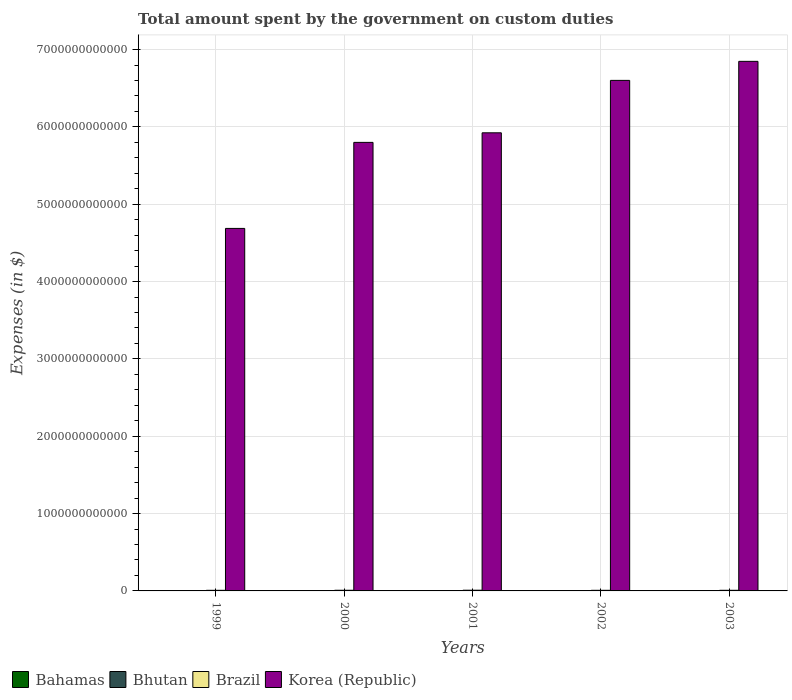How many different coloured bars are there?
Keep it short and to the point. 4. Are the number of bars per tick equal to the number of legend labels?
Ensure brevity in your answer.  Yes. How many bars are there on the 5th tick from the left?
Ensure brevity in your answer.  4. In how many cases, is the number of bars for a given year not equal to the number of legend labels?
Your response must be concise. 0. What is the amount spent on custom duties by the government in Korea (Republic) in 2002?
Make the answer very short. 6.60e+12. Across all years, what is the maximum amount spent on custom duties by the government in Korea (Republic)?
Provide a succinct answer. 6.85e+12. Across all years, what is the minimum amount spent on custom duties by the government in Brazil?
Give a very brief answer. 7.92e+09. In which year was the amount spent on custom duties by the government in Korea (Republic) minimum?
Make the answer very short. 1999. What is the total amount spent on custom duties by the government in Korea (Republic) in the graph?
Your answer should be very brief. 2.99e+13. What is the difference between the amount spent on custom duties by the government in Brazil in 2000 and that in 2003?
Give a very brief answer. 3.68e+08. What is the difference between the amount spent on custom duties by the government in Brazil in 2002 and the amount spent on custom duties by the government in Bhutan in 1999?
Provide a short and direct response. 7.93e+09. What is the average amount spent on custom duties by the government in Bahamas per year?
Provide a short and direct response. 4.08e+08. In the year 2000, what is the difference between the amount spent on custom duties by the government in Korea (Republic) and amount spent on custom duties by the government in Bhutan?
Your answer should be very brief. 5.80e+12. What is the ratio of the amount spent on custom duties by the government in Bhutan in 2001 to that in 2002?
Ensure brevity in your answer.  0.83. Is the amount spent on custom duties by the government in Bahamas in 1999 less than that in 2001?
Offer a very short reply. Yes. What is the difference between the highest and the second highest amount spent on custom duties by the government in Korea (Republic)?
Give a very brief answer. 2.46e+11. What is the difference between the highest and the lowest amount spent on custom duties by the government in Brazil?
Keep it short and to the point. 1.17e+09. Is the sum of the amount spent on custom duties by the government in Bahamas in 2000 and 2002 greater than the maximum amount spent on custom duties by the government in Korea (Republic) across all years?
Provide a short and direct response. No. Is it the case that in every year, the sum of the amount spent on custom duties by the government in Brazil and amount spent on custom duties by the government in Bahamas is greater than the sum of amount spent on custom duties by the government in Bhutan and amount spent on custom duties by the government in Korea (Republic)?
Your answer should be very brief. Yes. What does the 1st bar from the left in 2001 represents?
Keep it short and to the point. Bahamas. Are all the bars in the graph horizontal?
Your answer should be very brief. No. What is the difference between two consecutive major ticks on the Y-axis?
Your response must be concise. 1.00e+12. Does the graph contain any zero values?
Your response must be concise. No. Where does the legend appear in the graph?
Give a very brief answer. Bottom left. What is the title of the graph?
Give a very brief answer. Total amount spent by the government on custom duties. Does "American Samoa" appear as one of the legend labels in the graph?
Provide a succinct answer. No. What is the label or title of the X-axis?
Offer a terse response. Years. What is the label or title of the Y-axis?
Offer a terse response. Expenses (in $). What is the Expenses (in $) in Bahamas in 1999?
Make the answer very short. 3.98e+08. What is the Expenses (in $) of Bhutan in 1999?
Keep it short and to the point. 4.42e+07. What is the Expenses (in $) of Brazil in 1999?
Provide a succinct answer. 7.92e+09. What is the Expenses (in $) in Korea (Republic) in 1999?
Your answer should be very brief. 4.69e+12. What is the Expenses (in $) of Bahamas in 2000?
Your response must be concise. 4.11e+08. What is the Expenses (in $) of Bhutan in 2000?
Your response must be concise. 5.79e+07. What is the Expenses (in $) in Brazil in 2000?
Offer a very short reply. 8.51e+09. What is the Expenses (in $) in Korea (Republic) in 2000?
Make the answer very short. 5.80e+12. What is the Expenses (in $) in Bahamas in 2001?
Offer a very short reply. 4.11e+08. What is the Expenses (in $) in Bhutan in 2001?
Keep it short and to the point. 7.83e+07. What is the Expenses (in $) of Brazil in 2001?
Keep it short and to the point. 9.09e+09. What is the Expenses (in $) in Korea (Republic) in 2001?
Offer a very short reply. 5.92e+12. What is the Expenses (in $) of Bahamas in 2002?
Offer a very short reply. 3.96e+08. What is the Expenses (in $) of Bhutan in 2002?
Your answer should be very brief. 9.45e+07. What is the Expenses (in $) of Brazil in 2002?
Offer a very short reply. 7.97e+09. What is the Expenses (in $) of Korea (Republic) in 2002?
Keep it short and to the point. 6.60e+12. What is the Expenses (in $) in Bahamas in 2003?
Offer a terse response. 4.22e+08. What is the Expenses (in $) in Bhutan in 2003?
Your answer should be very brief. 1.15e+08. What is the Expenses (in $) of Brazil in 2003?
Keep it short and to the point. 8.14e+09. What is the Expenses (in $) of Korea (Republic) in 2003?
Your answer should be compact. 6.85e+12. Across all years, what is the maximum Expenses (in $) of Bahamas?
Give a very brief answer. 4.22e+08. Across all years, what is the maximum Expenses (in $) in Bhutan?
Your response must be concise. 1.15e+08. Across all years, what is the maximum Expenses (in $) in Brazil?
Provide a succinct answer. 9.09e+09. Across all years, what is the maximum Expenses (in $) in Korea (Republic)?
Provide a succinct answer. 6.85e+12. Across all years, what is the minimum Expenses (in $) of Bahamas?
Offer a terse response. 3.96e+08. Across all years, what is the minimum Expenses (in $) in Bhutan?
Offer a very short reply. 4.42e+07. Across all years, what is the minimum Expenses (in $) of Brazil?
Give a very brief answer. 7.92e+09. Across all years, what is the minimum Expenses (in $) of Korea (Republic)?
Ensure brevity in your answer.  4.69e+12. What is the total Expenses (in $) in Bahamas in the graph?
Ensure brevity in your answer.  2.04e+09. What is the total Expenses (in $) of Bhutan in the graph?
Your response must be concise. 3.90e+08. What is the total Expenses (in $) of Brazil in the graph?
Keep it short and to the point. 4.16e+1. What is the total Expenses (in $) of Korea (Republic) in the graph?
Your answer should be compact. 2.99e+13. What is the difference between the Expenses (in $) in Bahamas in 1999 and that in 2000?
Offer a very short reply. -1.23e+07. What is the difference between the Expenses (in $) of Bhutan in 1999 and that in 2000?
Ensure brevity in your answer.  -1.37e+07. What is the difference between the Expenses (in $) in Brazil in 1999 and that in 2000?
Keep it short and to the point. -5.94e+08. What is the difference between the Expenses (in $) of Korea (Republic) in 1999 and that in 2000?
Offer a very short reply. -1.11e+12. What is the difference between the Expenses (in $) of Bahamas in 1999 and that in 2001?
Ensure brevity in your answer.  -1.29e+07. What is the difference between the Expenses (in $) in Bhutan in 1999 and that in 2001?
Give a very brief answer. -3.41e+07. What is the difference between the Expenses (in $) of Brazil in 1999 and that in 2001?
Your answer should be very brief. -1.17e+09. What is the difference between the Expenses (in $) of Korea (Republic) in 1999 and that in 2001?
Your answer should be compact. -1.24e+12. What is the difference between the Expenses (in $) of Bahamas in 1999 and that in 2002?
Make the answer very short. 2.16e+06. What is the difference between the Expenses (in $) in Bhutan in 1999 and that in 2002?
Your response must be concise. -5.03e+07. What is the difference between the Expenses (in $) in Brazil in 1999 and that in 2002?
Ensure brevity in your answer.  -5.38e+07. What is the difference between the Expenses (in $) of Korea (Republic) in 1999 and that in 2002?
Offer a terse response. -1.91e+12. What is the difference between the Expenses (in $) in Bahamas in 1999 and that in 2003?
Offer a terse response. -2.34e+07. What is the difference between the Expenses (in $) of Bhutan in 1999 and that in 2003?
Your answer should be very brief. -7.10e+07. What is the difference between the Expenses (in $) of Brazil in 1999 and that in 2003?
Give a very brief answer. -2.26e+08. What is the difference between the Expenses (in $) in Korea (Republic) in 1999 and that in 2003?
Your response must be concise. -2.16e+12. What is the difference between the Expenses (in $) of Bahamas in 2000 and that in 2001?
Provide a short and direct response. -6.24e+05. What is the difference between the Expenses (in $) of Bhutan in 2000 and that in 2001?
Ensure brevity in your answer.  -2.04e+07. What is the difference between the Expenses (in $) of Brazil in 2000 and that in 2001?
Make the answer very short. -5.77e+08. What is the difference between the Expenses (in $) in Korea (Republic) in 2000 and that in 2001?
Give a very brief answer. -1.24e+11. What is the difference between the Expenses (in $) of Bahamas in 2000 and that in 2002?
Your response must be concise. 1.45e+07. What is the difference between the Expenses (in $) in Bhutan in 2000 and that in 2002?
Keep it short and to the point. -3.66e+07. What is the difference between the Expenses (in $) in Brazil in 2000 and that in 2002?
Ensure brevity in your answer.  5.40e+08. What is the difference between the Expenses (in $) in Korea (Republic) in 2000 and that in 2002?
Your answer should be compact. -8.02e+11. What is the difference between the Expenses (in $) in Bahamas in 2000 and that in 2003?
Your answer should be very brief. -1.11e+07. What is the difference between the Expenses (in $) of Bhutan in 2000 and that in 2003?
Your answer should be very brief. -5.73e+07. What is the difference between the Expenses (in $) in Brazil in 2000 and that in 2003?
Provide a short and direct response. 3.68e+08. What is the difference between the Expenses (in $) of Korea (Republic) in 2000 and that in 2003?
Make the answer very short. -1.05e+12. What is the difference between the Expenses (in $) of Bahamas in 2001 and that in 2002?
Give a very brief answer. 1.51e+07. What is the difference between the Expenses (in $) of Bhutan in 2001 and that in 2002?
Give a very brief answer. -1.62e+07. What is the difference between the Expenses (in $) in Brazil in 2001 and that in 2002?
Your answer should be very brief. 1.12e+09. What is the difference between the Expenses (in $) in Korea (Republic) in 2001 and that in 2002?
Offer a very short reply. -6.78e+11. What is the difference between the Expenses (in $) in Bahamas in 2001 and that in 2003?
Your answer should be compact. -1.05e+07. What is the difference between the Expenses (in $) of Bhutan in 2001 and that in 2003?
Your answer should be compact. -3.69e+07. What is the difference between the Expenses (in $) in Brazil in 2001 and that in 2003?
Provide a succinct answer. 9.45e+08. What is the difference between the Expenses (in $) in Korea (Republic) in 2001 and that in 2003?
Your response must be concise. -9.24e+11. What is the difference between the Expenses (in $) of Bahamas in 2002 and that in 2003?
Keep it short and to the point. -2.56e+07. What is the difference between the Expenses (in $) in Bhutan in 2002 and that in 2003?
Offer a very short reply. -2.06e+07. What is the difference between the Expenses (in $) of Brazil in 2002 and that in 2003?
Your response must be concise. -1.72e+08. What is the difference between the Expenses (in $) in Korea (Republic) in 2002 and that in 2003?
Offer a terse response. -2.46e+11. What is the difference between the Expenses (in $) in Bahamas in 1999 and the Expenses (in $) in Bhutan in 2000?
Your answer should be very brief. 3.40e+08. What is the difference between the Expenses (in $) of Bahamas in 1999 and the Expenses (in $) of Brazil in 2000?
Keep it short and to the point. -8.11e+09. What is the difference between the Expenses (in $) in Bahamas in 1999 and the Expenses (in $) in Korea (Republic) in 2000?
Keep it short and to the point. -5.80e+12. What is the difference between the Expenses (in $) in Bhutan in 1999 and the Expenses (in $) in Brazil in 2000?
Your answer should be compact. -8.47e+09. What is the difference between the Expenses (in $) in Bhutan in 1999 and the Expenses (in $) in Korea (Republic) in 2000?
Keep it short and to the point. -5.80e+12. What is the difference between the Expenses (in $) of Brazil in 1999 and the Expenses (in $) of Korea (Republic) in 2000?
Offer a terse response. -5.79e+12. What is the difference between the Expenses (in $) of Bahamas in 1999 and the Expenses (in $) of Bhutan in 2001?
Make the answer very short. 3.20e+08. What is the difference between the Expenses (in $) in Bahamas in 1999 and the Expenses (in $) in Brazil in 2001?
Give a very brief answer. -8.69e+09. What is the difference between the Expenses (in $) in Bahamas in 1999 and the Expenses (in $) in Korea (Republic) in 2001?
Provide a short and direct response. -5.92e+12. What is the difference between the Expenses (in $) of Bhutan in 1999 and the Expenses (in $) of Brazil in 2001?
Ensure brevity in your answer.  -9.04e+09. What is the difference between the Expenses (in $) of Bhutan in 1999 and the Expenses (in $) of Korea (Republic) in 2001?
Offer a terse response. -5.92e+12. What is the difference between the Expenses (in $) in Brazil in 1999 and the Expenses (in $) in Korea (Republic) in 2001?
Provide a succinct answer. -5.92e+12. What is the difference between the Expenses (in $) of Bahamas in 1999 and the Expenses (in $) of Bhutan in 2002?
Offer a terse response. 3.04e+08. What is the difference between the Expenses (in $) of Bahamas in 1999 and the Expenses (in $) of Brazil in 2002?
Your response must be concise. -7.57e+09. What is the difference between the Expenses (in $) of Bahamas in 1999 and the Expenses (in $) of Korea (Republic) in 2002?
Keep it short and to the point. -6.60e+12. What is the difference between the Expenses (in $) of Bhutan in 1999 and the Expenses (in $) of Brazil in 2002?
Provide a succinct answer. -7.93e+09. What is the difference between the Expenses (in $) in Bhutan in 1999 and the Expenses (in $) in Korea (Republic) in 2002?
Offer a very short reply. -6.60e+12. What is the difference between the Expenses (in $) of Brazil in 1999 and the Expenses (in $) of Korea (Republic) in 2002?
Provide a succinct answer. -6.59e+12. What is the difference between the Expenses (in $) in Bahamas in 1999 and the Expenses (in $) in Bhutan in 2003?
Offer a terse response. 2.83e+08. What is the difference between the Expenses (in $) in Bahamas in 1999 and the Expenses (in $) in Brazil in 2003?
Provide a short and direct response. -7.74e+09. What is the difference between the Expenses (in $) in Bahamas in 1999 and the Expenses (in $) in Korea (Republic) in 2003?
Your answer should be compact. -6.85e+12. What is the difference between the Expenses (in $) of Bhutan in 1999 and the Expenses (in $) of Brazil in 2003?
Ensure brevity in your answer.  -8.10e+09. What is the difference between the Expenses (in $) in Bhutan in 1999 and the Expenses (in $) in Korea (Republic) in 2003?
Provide a short and direct response. -6.85e+12. What is the difference between the Expenses (in $) in Brazil in 1999 and the Expenses (in $) in Korea (Republic) in 2003?
Ensure brevity in your answer.  -6.84e+12. What is the difference between the Expenses (in $) of Bahamas in 2000 and the Expenses (in $) of Bhutan in 2001?
Keep it short and to the point. 3.32e+08. What is the difference between the Expenses (in $) of Bahamas in 2000 and the Expenses (in $) of Brazil in 2001?
Offer a very short reply. -8.68e+09. What is the difference between the Expenses (in $) of Bahamas in 2000 and the Expenses (in $) of Korea (Republic) in 2001?
Your answer should be very brief. -5.92e+12. What is the difference between the Expenses (in $) of Bhutan in 2000 and the Expenses (in $) of Brazil in 2001?
Your response must be concise. -9.03e+09. What is the difference between the Expenses (in $) in Bhutan in 2000 and the Expenses (in $) in Korea (Republic) in 2001?
Ensure brevity in your answer.  -5.92e+12. What is the difference between the Expenses (in $) of Brazil in 2000 and the Expenses (in $) of Korea (Republic) in 2001?
Offer a terse response. -5.91e+12. What is the difference between the Expenses (in $) of Bahamas in 2000 and the Expenses (in $) of Bhutan in 2002?
Your response must be concise. 3.16e+08. What is the difference between the Expenses (in $) in Bahamas in 2000 and the Expenses (in $) in Brazil in 2002?
Provide a succinct answer. -7.56e+09. What is the difference between the Expenses (in $) of Bahamas in 2000 and the Expenses (in $) of Korea (Republic) in 2002?
Offer a terse response. -6.60e+12. What is the difference between the Expenses (in $) of Bhutan in 2000 and the Expenses (in $) of Brazil in 2002?
Your answer should be compact. -7.91e+09. What is the difference between the Expenses (in $) in Bhutan in 2000 and the Expenses (in $) in Korea (Republic) in 2002?
Your answer should be compact. -6.60e+12. What is the difference between the Expenses (in $) in Brazil in 2000 and the Expenses (in $) in Korea (Republic) in 2002?
Give a very brief answer. -6.59e+12. What is the difference between the Expenses (in $) in Bahamas in 2000 and the Expenses (in $) in Bhutan in 2003?
Ensure brevity in your answer.  2.96e+08. What is the difference between the Expenses (in $) of Bahamas in 2000 and the Expenses (in $) of Brazil in 2003?
Ensure brevity in your answer.  -7.73e+09. What is the difference between the Expenses (in $) of Bahamas in 2000 and the Expenses (in $) of Korea (Republic) in 2003?
Provide a succinct answer. -6.85e+12. What is the difference between the Expenses (in $) in Bhutan in 2000 and the Expenses (in $) in Brazil in 2003?
Offer a terse response. -8.08e+09. What is the difference between the Expenses (in $) in Bhutan in 2000 and the Expenses (in $) in Korea (Republic) in 2003?
Keep it short and to the point. -6.85e+12. What is the difference between the Expenses (in $) of Brazil in 2000 and the Expenses (in $) of Korea (Republic) in 2003?
Make the answer very short. -6.84e+12. What is the difference between the Expenses (in $) in Bahamas in 2001 and the Expenses (in $) in Bhutan in 2002?
Provide a succinct answer. 3.17e+08. What is the difference between the Expenses (in $) in Bahamas in 2001 and the Expenses (in $) in Brazil in 2002?
Keep it short and to the point. -7.56e+09. What is the difference between the Expenses (in $) in Bahamas in 2001 and the Expenses (in $) in Korea (Republic) in 2002?
Give a very brief answer. -6.60e+12. What is the difference between the Expenses (in $) of Bhutan in 2001 and the Expenses (in $) of Brazil in 2002?
Provide a succinct answer. -7.89e+09. What is the difference between the Expenses (in $) in Bhutan in 2001 and the Expenses (in $) in Korea (Republic) in 2002?
Keep it short and to the point. -6.60e+12. What is the difference between the Expenses (in $) of Brazil in 2001 and the Expenses (in $) of Korea (Republic) in 2002?
Give a very brief answer. -6.59e+12. What is the difference between the Expenses (in $) in Bahamas in 2001 and the Expenses (in $) in Bhutan in 2003?
Offer a terse response. 2.96e+08. What is the difference between the Expenses (in $) in Bahamas in 2001 and the Expenses (in $) in Brazil in 2003?
Make the answer very short. -7.73e+09. What is the difference between the Expenses (in $) in Bahamas in 2001 and the Expenses (in $) in Korea (Republic) in 2003?
Offer a very short reply. -6.85e+12. What is the difference between the Expenses (in $) of Bhutan in 2001 and the Expenses (in $) of Brazil in 2003?
Your answer should be very brief. -8.06e+09. What is the difference between the Expenses (in $) of Bhutan in 2001 and the Expenses (in $) of Korea (Republic) in 2003?
Offer a terse response. -6.85e+12. What is the difference between the Expenses (in $) of Brazil in 2001 and the Expenses (in $) of Korea (Republic) in 2003?
Keep it short and to the point. -6.84e+12. What is the difference between the Expenses (in $) in Bahamas in 2002 and the Expenses (in $) in Bhutan in 2003?
Your answer should be compact. 2.81e+08. What is the difference between the Expenses (in $) of Bahamas in 2002 and the Expenses (in $) of Brazil in 2003?
Make the answer very short. -7.75e+09. What is the difference between the Expenses (in $) in Bahamas in 2002 and the Expenses (in $) in Korea (Republic) in 2003?
Keep it short and to the point. -6.85e+12. What is the difference between the Expenses (in $) of Bhutan in 2002 and the Expenses (in $) of Brazil in 2003?
Provide a succinct answer. -8.05e+09. What is the difference between the Expenses (in $) of Bhutan in 2002 and the Expenses (in $) of Korea (Republic) in 2003?
Offer a terse response. -6.85e+12. What is the difference between the Expenses (in $) in Brazil in 2002 and the Expenses (in $) in Korea (Republic) in 2003?
Give a very brief answer. -6.84e+12. What is the average Expenses (in $) in Bahamas per year?
Offer a terse response. 4.08e+08. What is the average Expenses (in $) in Bhutan per year?
Give a very brief answer. 7.80e+07. What is the average Expenses (in $) of Brazil per year?
Ensure brevity in your answer.  8.33e+09. What is the average Expenses (in $) of Korea (Republic) per year?
Offer a very short reply. 5.97e+12. In the year 1999, what is the difference between the Expenses (in $) in Bahamas and Expenses (in $) in Bhutan?
Provide a succinct answer. 3.54e+08. In the year 1999, what is the difference between the Expenses (in $) in Bahamas and Expenses (in $) in Brazil?
Ensure brevity in your answer.  -7.52e+09. In the year 1999, what is the difference between the Expenses (in $) in Bahamas and Expenses (in $) in Korea (Republic)?
Give a very brief answer. -4.69e+12. In the year 1999, what is the difference between the Expenses (in $) in Bhutan and Expenses (in $) in Brazil?
Offer a terse response. -7.87e+09. In the year 1999, what is the difference between the Expenses (in $) in Bhutan and Expenses (in $) in Korea (Republic)?
Your answer should be very brief. -4.69e+12. In the year 1999, what is the difference between the Expenses (in $) in Brazil and Expenses (in $) in Korea (Republic)?
Your response must be concise. -4.68e+12. In the year 2000, what is the difference between the Expenses (in $) of Bahamas and Expenses (in $) of Bhutan?
Your response must be concise. 3.53e+08. In the year 2000, what is the difference between the Expenses (in $) in Bahamas and Expenses (in $) in Brazil?
Your response must be concise. -8.10e+09. In the year 2000, what is the difference between the Expenses (in $) of Bahamas and Expenses (in $) of Korea (Republic)?
Your answer should be very brief. -5.80e+12. In the year 2000, what is the difference between the Expenses (in $) of Bhutan and Expenses (in $) of Brazil?
Your answer should be very brief. -8.45e+09. In the year 2000, what is the difference between the Expenses (in $) of Bhutan and Expenses (in $) of Korea (Republic)?
Make the answer very short. -5.80e+12. In the year 2000, what is the difference between the Expenses (in $) in Brazil and Expenses (in $) in Korea (Republic)?
Provide a short and direct response. -5.79e+12. In the year 2001, what is the difference between the Expenses (in $) in Bahamas and Expenses (in $) in Bhutan?
Your response must be concise. 3.33e+08. In the year 2001, what is the difference between the Expenses (in $) in Bahamas and Expenses (in $) in Brazil?
Make the answer very short. -8.68e+09. In the year 2001, what is the difference between the Expenses (in $) in Bahamas and Expenses (in $) in Korea (Republic)?
Your answer should be compact. -5.92e+12. In the year 2001, what is the difference between the Expenses (in $) in Bhutan and Expenses (in $) in Brazil?
Provide a short and direct response. -9.01e+09. In the year 2001, what is the difference between the Expenses (in $) in Bhutan and Expenses (in $) in Korea (Republic)?
Give a very brief answer. -5.92e+12. In the year 2001, what is the difference between the Expenses (in $) in Brazil and Expenses (in $) in Korea (Republic)?
Your answer should be very brief. -5.91e+12. In the year 2002, what is the difference between the Expenses (in $) in Bahamas and Expenses (in $) in Bhutan?
Provide a succinct answer. 3.02e+08. In the year 2002, what is the difference between the Expenses (in $) in Bahamas and Expenses (in $) in Brazil?
Keep it short and to the point. -7.57e+09. In the year 2002, what is the difference between the Expenses (in $) in Bahamas and Expenses (in $) in Korea (Republic)?
Your answer should be very brief. -6.60e+12. In the year 2002, what is the difference between the Expenses (in $) in Bhutan and Expenses (in $) in Brazil?
Provide a short and direct response. -7.88e+09. In the year 2002, what is the difference between the Expenses (in $) in Bhutan and Expenses (in $) in Korea (Republic)?
Your answer should be very brief. -6.60e+12. In the year 2002, what is the difference between the Expenses (in $) in Brazil and Expenses (in $) in Korea (Republic)?
Your response must be concise. -6.59e+12. In the year 2003, what is the difference between the Expenses (in $) in Bahamas and Expenses (in $) in Bhutan?
Your answer should be very brief. 3.07e+08. In the year 2003, what is the difference between the Expenses (in $) in Bahamas and Expenses (in $) in Brazil?
Your answer should be very brief. -7.72e+09. In the year 2003, what is the difference between the Expenses (in $) in Bahamas and Expenses (in $) in Korea (Republic)?
Offer a very short reply. -6.85e+12. In the year 2003, what is the difference between the Expenses (in $) in Bhutan and Expenses (in $) in Brazil?
Your answer should be compact. -8.03e+09. In the year 2003, what is the difference between the Expenses (in $) in Bhutan and Expenses (in $) in Korea (Republic)?
Give a very brief answer. -6.85e+12. In the year 2003, what is the difference between the Expenses (in $) in Brazil and Expenses (in $) in Korea (Republic)?
Provide a short and direct response. -6.84e+12. What is the ratio of the Expenses (in $) in Bhutan in 1999 to that in 2000?
Your answer should be very brief. 0.76. What is the ratio of the Expenses (in $) in Brazil in 1999 to that in 2000?
Offer a terse response. 0.93. What is the ratio of the Expenses (in $) of Korea (Republic) in 1999 to that in 2000?
Ensure brevity in your answer.  0.81. What is the ratio of the Expenses (in $) of Bahamas in 1999 to that in 2001?
Give a very brief answer. 0.97. What is the ratio of the Expenses (in $) in Bhutan in 1999 to that in 2001?
Your answer should be very brief. 0.56. What is the ratio of the Expenses (in $) of Brazil in 1999 to that in 2001?
Provide a succinct answer. 0.87. What is the ratio of the Expenses (in $) in Korea (Republic) in 1999 to that in 2001?
Offer a very short reply. 0.79. What is the ratio of the Expenses (in $) of Bhutan in 1999 to that in 2002?
Provide a succinct answer. 0.47. What is the ratio of the Expenses (in $) of Korea (Republic) in 1999 to that in 2002?
Provide a short and direct response. 0.71. What is the ratio of the Expenses (in $) in Bahamas in 1999 to that in 2003?
Your response must be concise. 0.94. What is the ratio of the Expenses (in $) in Bhutan in 1999 to that in 2003?
Your response must be concise. 0.38. What is the ratio of the Expenses (in $) in Brazil in 1999 to that in 2003?
Your answer should be very brief. 0.97. What is the ratio of the Expenses (in $) of Korea (Republic) in 1999 to that in 2003?
Give a very brief answer. 0.68. What is the ratio of the Expenses (in $) of Bhutan in 2000 to that in 2001?
Offer a terse response. 0.74. What is the ratio of the Expenses (in $) in Brazil in 2000 to that in 2001?
Your response must be concise. 0.94. What is the ratio of the Expenses (in $) in Korea (Republic) in 2000 to that in 2001?
Your response must be concise. 0.98. What is the ratio of the Expenses (in $) in Bahamas in 2000 to that in 2002?
Your response must be concise. 1.04. What is the ratio of the Expenses (in $) in Bhutan in 2000 to that in 2002?
Provide a short and direct response. 0.61. What is the ratio of the Expenses (in $) in Brazil in 2000 to that in 2002?
Make the answer very short. 1.07. What is the ratio of the Expenses (in $) in Korea (Republic) in 2000 to that in 2002?
Your answer should be very brief. 0.88. What is the ratio of the Expenses (in $) of Bahamas in 2000 to that in 2003?
Your answer should be compact. 0.97. What is the ratio of the Expenses (in $) in Bhutan in 2000 to that in 2003?
Your response must be concise. 0.5. What is the ratio of the Expenses (in $) in Brazil in 2000 to that in 2003?
Provide a short and direct response. 1.05. What is the ratio of the Expenses (in $) of Korea (Republic) in 2000 to that in 2003?
Make the answer very short. 0.85. What is the ratio of the Expenses (in $) in Bahamas in 2001 to that in 2002?
Offer a terse response. 1.04. What is the ratio of the Expenses (in $) in Bhutan in 2001 to that in 2002?
Your answer should be very brief. 0.83. What is the ratio of the Expenses (in $) in Brazil in 2001 to that in 2002?
Your answer should be very brief. 1.14. What is the ratio of the Expenses (in $) of Korea (Republic) in 2001 to that in 2002?
Provide a succinct answer. 0.9. What is the ratio of the Expenses (in $) of Bahamas in 2001 to that in 2003?
Your answer should be very brief. 0.98. What is the ratio of the Expenses (in $) in Bhutan in 2001 to that in 2003?
Provide a succinct answer. 0.68. What is the ratio of the Expenses (in $) in Brazil in 2001 to that in 2003?
Keep it short and to the point. 1.12. What is the ratio of the Expenses (in $) of Korea (Republic) in 2001 to that in 2003?
Provide a short and direct response. 0.87. What is the ratio of the Expenses (in $) of Bahamas in 2002 to that in 2003?
Your answer should be compact. 0.94. What is the ratio of the Expenses (in $) in Bhutan in 2002 to that in 2003?
Give a very brief answer. 0.82. What is the ratio of the Expenses (in $) of Brazil in 2002 to that in 2003?
Provide a short and direct response. 0.98. What is the ratio of the Expenses (in $) of Korea (Republic) in 2002 to that in 2003?
Give a very brief answer. 0.96. What is the difference between the highest and the second highest Expenses (in $) of Bahamas?
Your response must be concise. 1.05e+07. What is the difference between the highest and the second highest Expenses (in $) of Bhutan?
Keep it short and to the point. 2.06e+07. What is the difference between the highest and the second highest Expenses (in $) of Brazil?
Offer a very short reply. 5.77e+08. What is the difference between the highest and the second highest Expenses (in $) in Korea (Republic)?
Ensure brevity in your answer.  2.46e+11. What is the difference between the highest and the lowest Expenses (in $) in Bahamas?
Give a very brief answer. 2.56e+07. What is the difference between the highest and the lowest Expenses (in $) in Bhutan?
Keep it short and to the point. 7.10e+07. What is the difference between the highest and the lowest Expenses (in $) in Brazil?
Make the answer very short. 1.17e+09. What is the difference between the highest and the lowest Expenses (in $) in Korea (Republic)?
Provide a short and direct response. 2.16e+12. 